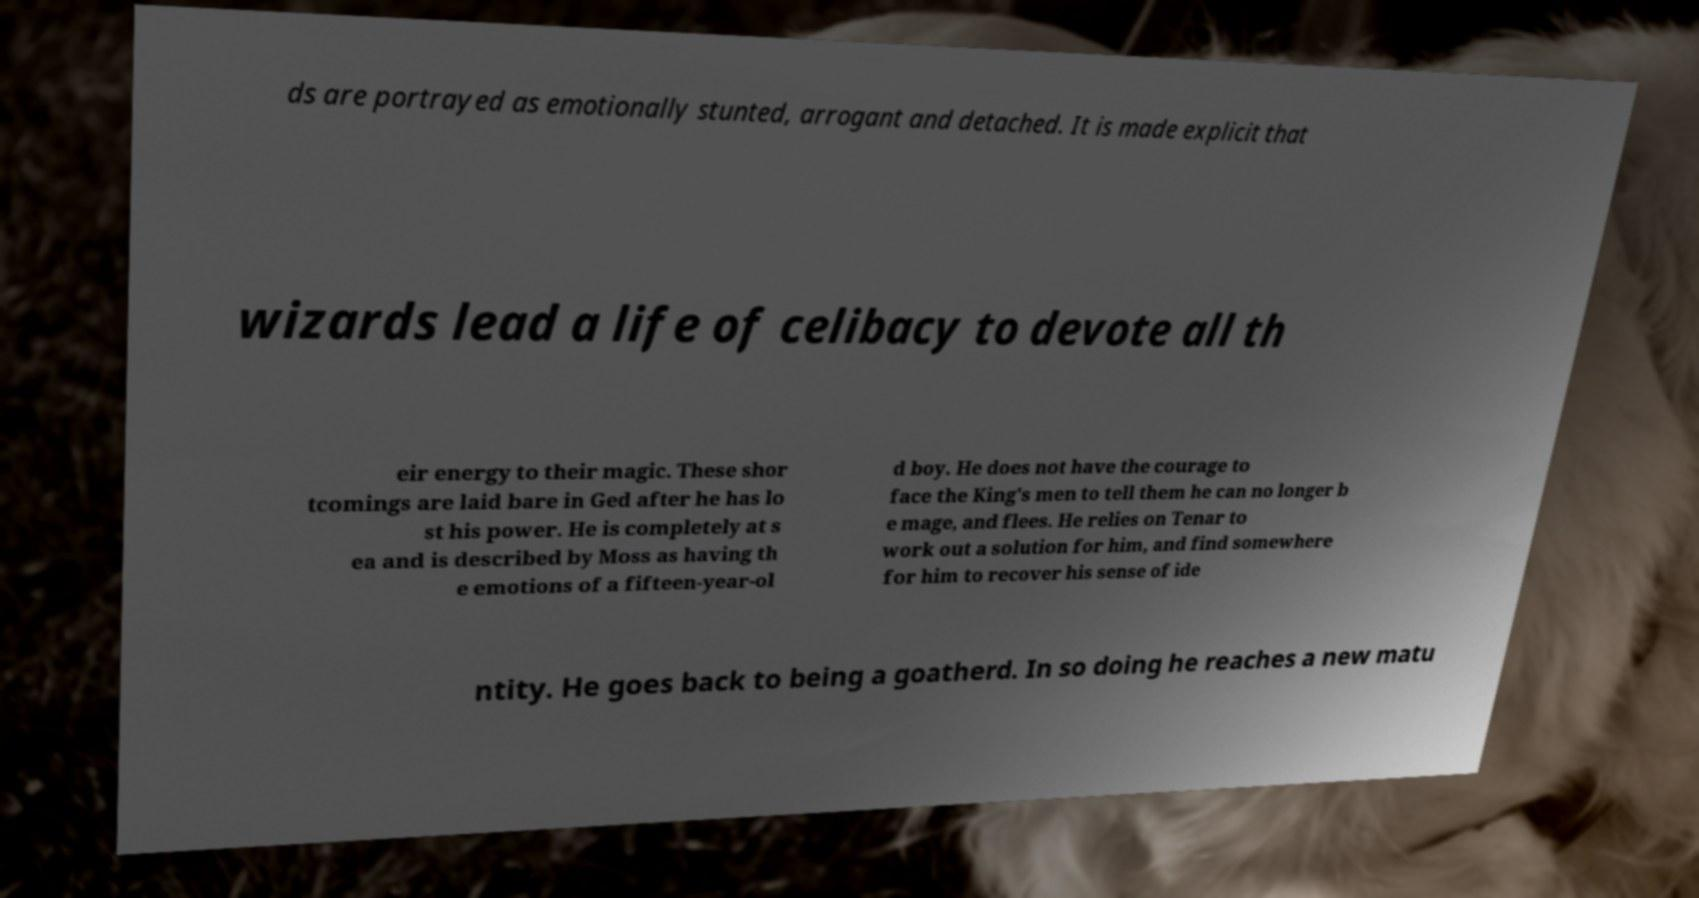Could you assist in decoding the text presented in this image and type it out clearly? ds are portrayed as emotionally stunted, arrogant and detached. It is made explicit that wizards lead a life of celibacy to devote all th eir energy to their magic. These shor tcomings are laid bare in Ged after he has lo st his power. He is completely at s ea and is described by Moss as having th e emotions of a fifteen-year-ol d boy. He does not have the courage to face the King's men to tell them he can no longer b e mage, and flees. He relies on Tenar to work out a solution for him, and find somewhere for him to recover his sense of ide ntity. He goes back to being a goatherd. In so doing he reaches a new matu 